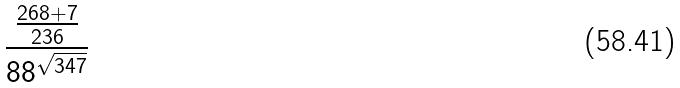Convert formula to latex. <formula><loc_0><loc_0><loc_500><loc_500>\frac { \frac { 2 6 8 + 7 } { 2 3 6 } } { 8 8 ^ { \sqrt { 3 4 7 } } }</formula> 